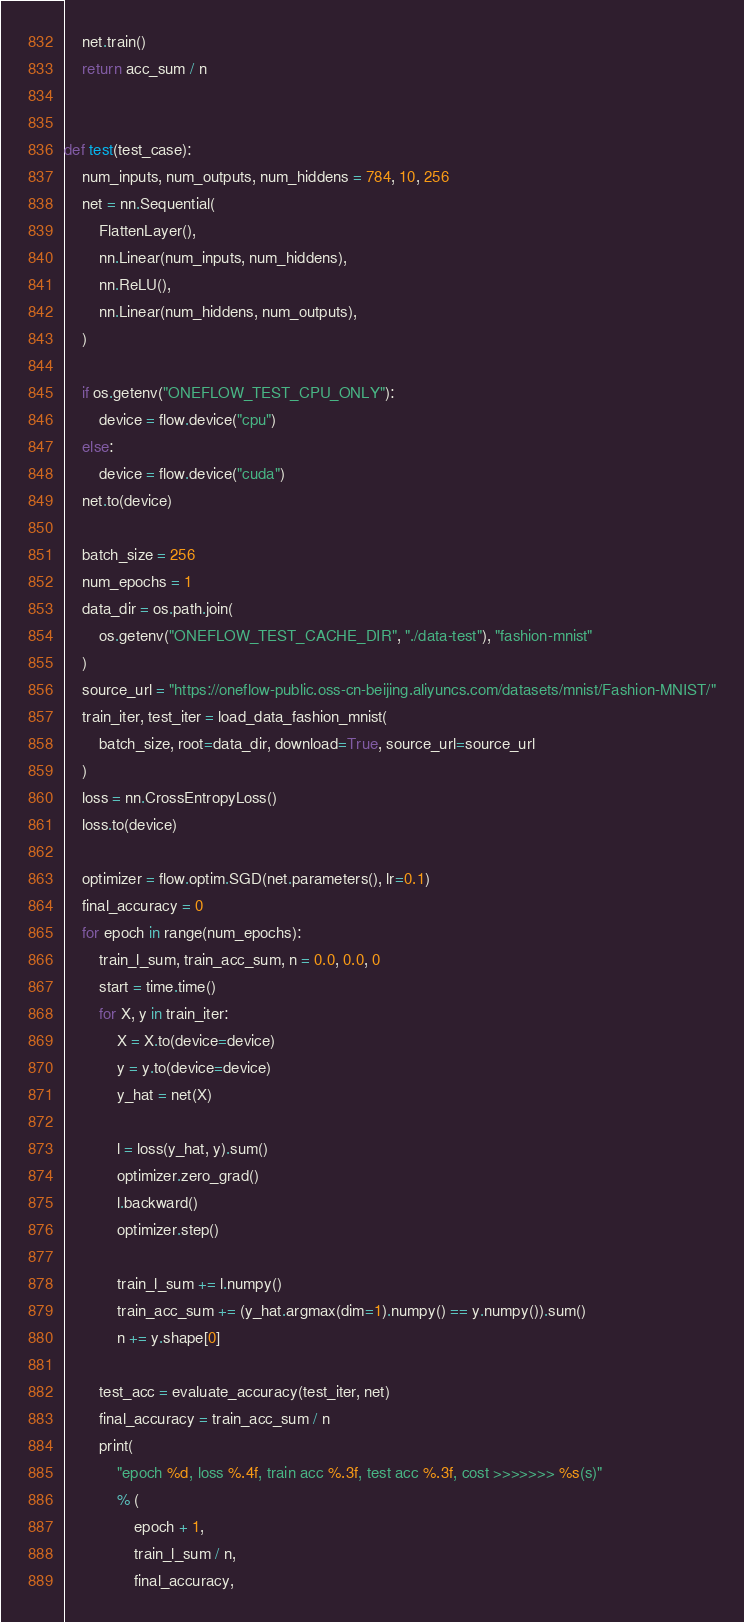<code> <loc_0><loc_0><loc_500><loc_500><_Python_>    net.train()
    return acc_sum / n


def test(test_case):
    num_inputs, num_outputs, num_hiddens = 784, 10, 256
    net = nn.Sequential(
        FlattenLayer(),
        nn.Linear(num_inputs, num_hiddens),
        nn.ReLU(),
        nn.Linear(num_hiddens, num_outputs),
    )

    if os.getenv("ONEFLOW_TEST_CPU_ONLY"):
        device = flow.device("cpu")
    else:
        device = flow.device("cuda")
    net.to(device)

    batch_size = 256
    num_epochs = 1
    data_dir = os.path.join(
        os.getenv("ONEFLOW_TEST_CACHE_DIR", "./data-test"), "fashion-mnist"
    )
    source_url = "https://oneflow-public.oss-cn-beijing.aliyuncs.com/datasets/mnist/Fashion-MNIST/"
    train_iter, test_iter = load_data_fashion_mnist(
        batch_size, root=data_dir, download=True, source_url=source_url
    )
    loss = nn.CrossEntropyLoss()
    loss.to(device)

    optimizer = flow.optim.SGD(net.parameters(), lr=0.1)
    final_accuracy = 0
    for epoch in range(num_epochs):
        train_l_sum, train_acc_sum, n = 0.0, 0.0, 0
        start = time.time()
        for X, y in train_iter:
            X = X.to(device=device)
            y = y.to(device=device)
            y_hat = net(X)

            l = loss(y_hat, y).sum()
            optimizer.zero_grad()
            l.backward()
            optimizer.step()

            train_l_sum += l.numpy()
            train_acc_sum += (y_hat.argmax(dim=1).numpy() == y.numpy()).sum()
            n += y.shape[0]

        test_acc = evaluate_accuracy(test_iter, net)
        final_accuracy = train_acc_sum / n
        print(
            "epoch %d, loss %.4f, train acc %.3f, test acc %.3f, cost >>>>>>> %s(s)"
            % (
                epoch + 1,
                train_l_sum / n,
                final_accuracy,</code> 